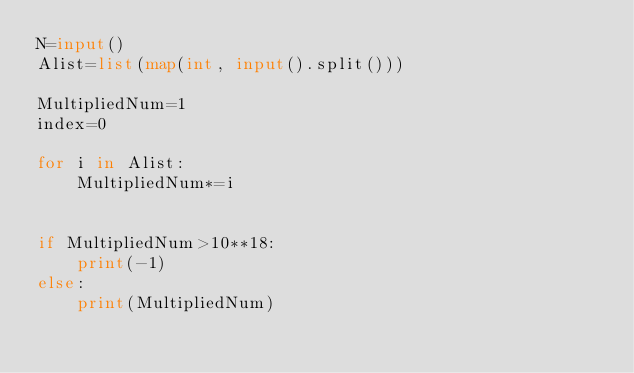<code> <loc_0><loc_0><loc_500><loc_500><_Python_>N=input()
Alist=list(map(int, input().split()))

MultipliedNum=1
index=0

for i in Alist:
    MultipliedNum*=i
    

if MultipliedNum>10**18:
    print(-1)
else:
    print(MultipliedNum)</code> 